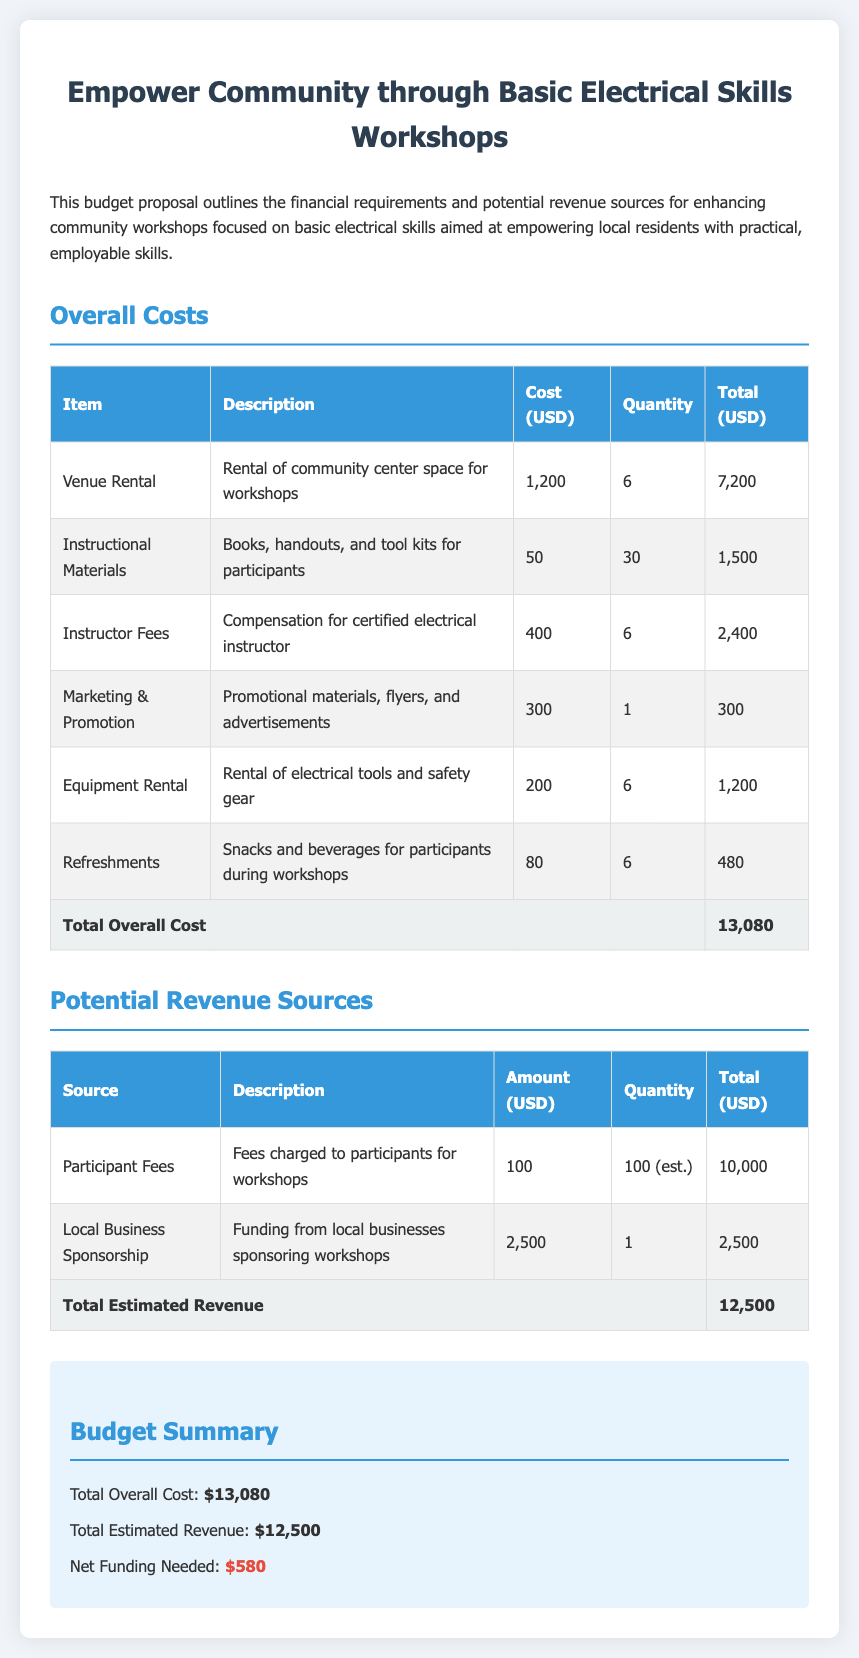what is the total overall cost? The total overall cost is the sum of all expenses listed in the budget section, which amounts to $7,200 + $1,500 + $2,400 + $300 + $1,200 + $480 = $13,080.
Answer: $13,080 how many workshops are planned? The budget proposal states that there are six workshops planned, as indicated by the quantity for venue rental, instructor fees, equipment rental, etc.
Answer: 6 what is the cost for instructional materials per participant? The cost for instructional materials is $50, as listed in the budget table under the description for instructional materials.
Answer: $50 what is the total estimated revenue? The total estimated revenue is the sum of all revenue sources mentioned in the document, which is $10,000 + $2,500 = $12,500.
Answer: $12,500 how much net funding is needed? The net funding needed is calculated by subtracting total estimated revenue from total overall cost, which is $13,080 - $12,500 = $580.
Answer: $580 what is the cost for instructor fees? The cost for instructor fees is $400 per workshop, as shown in the budget under the instructor fees section.
Answer: $400 how many participants are estimated for the workshops? The budget estimates 100 participants, as the quantity mentioned under participant fees is 100 (est.).
Answer: 100 what is the budgeted amount for marketing and promotion? The budgeted amount for marketing and promotion is $300, which is explicitly listed in the budget table.
Answer: $300 what is the total cost for refreshments over the workshops? The total cost for refreshments is $80 per workshop for six workshops, resulting in a total cost of $480.
Answer: $480 